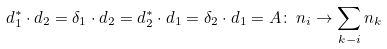<formula> <loc_0><loc_0><loc_500><loc_500>d _ { 1 } ^ { * } \cdot d _ { 2 } = \delta _ { 1 } \cdot d _ { 2 } = d _ { 2 } ^ { * } \cdot d _ { 1 } = \delta _ { 2 } \cdot d _ { 1 } = A \colon \, n _ { i } \to \sum _ { k - i } n _ { k }</formula> 